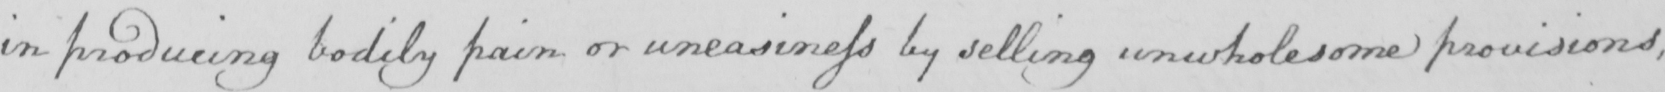What does this handwritten line say? in producing bodily pain or uneasiness by selling unwholesome provisions, 